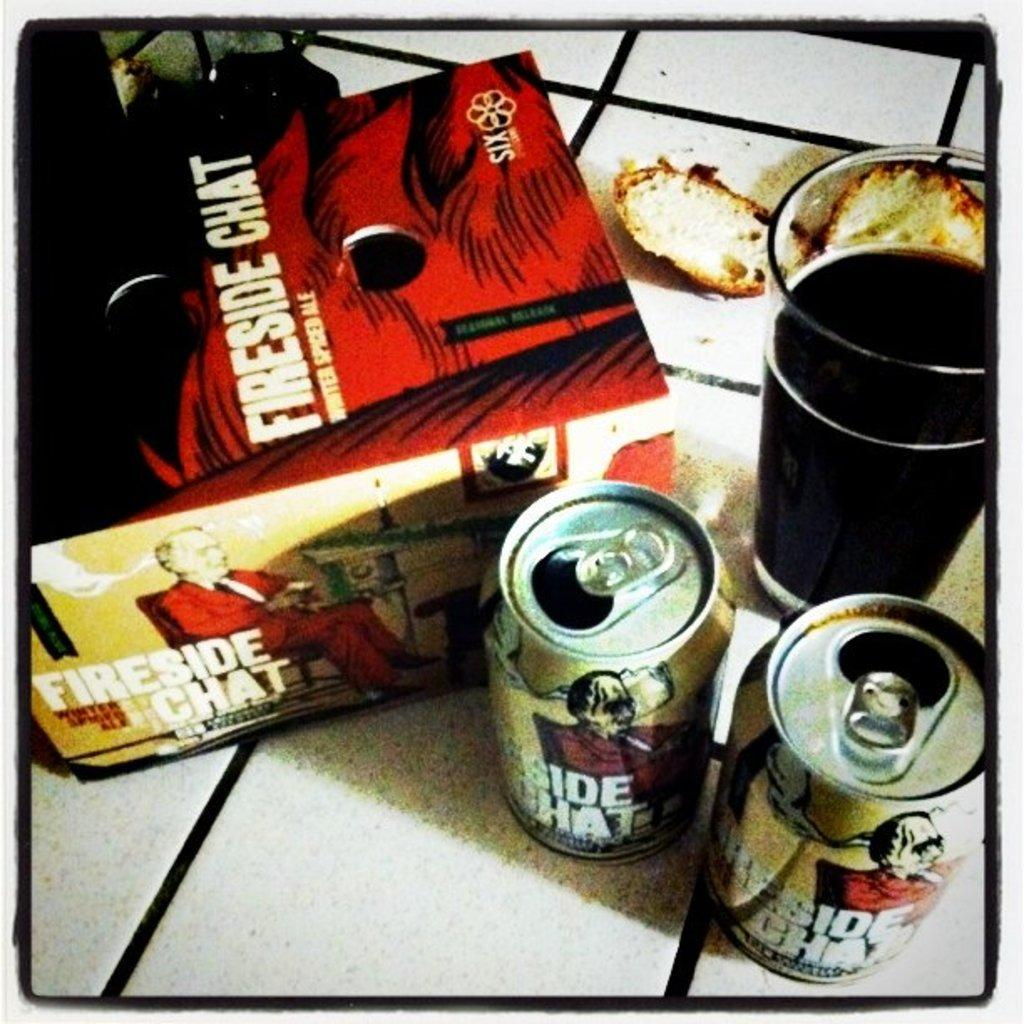<image>
Give a short and clear explanation of the subsequent image. A box that says Fireside Chat sits next to two open cans. 